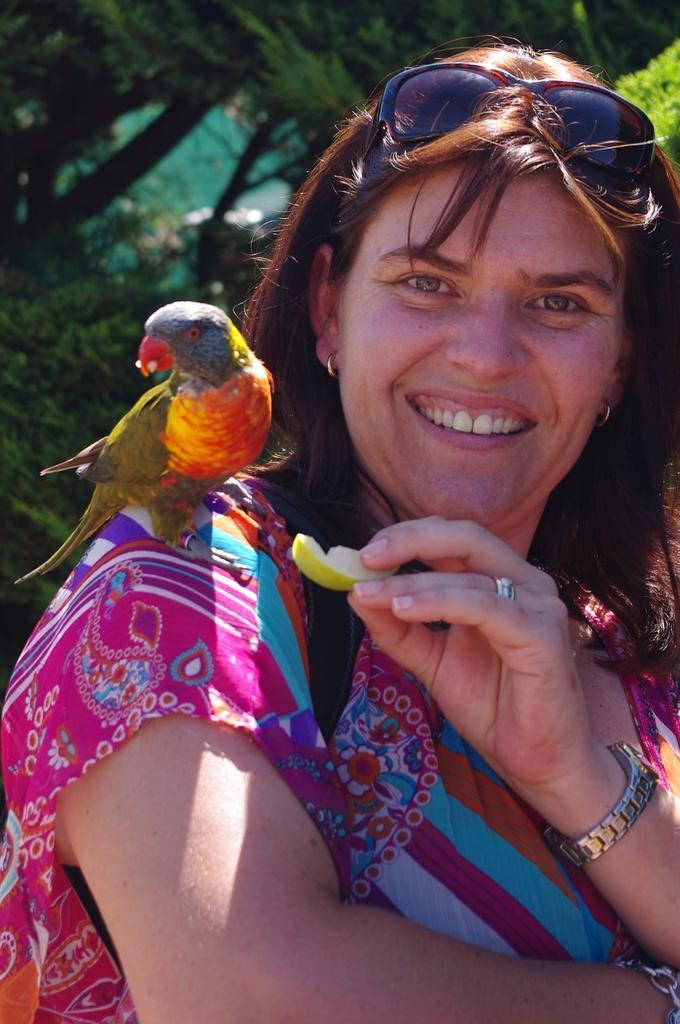In one or two sentences, can you explain what this image depicts? Here we can see a woman holding a fruit with her hand and there is a bird on her shoulder. She is smiling. In the background there are trees. 